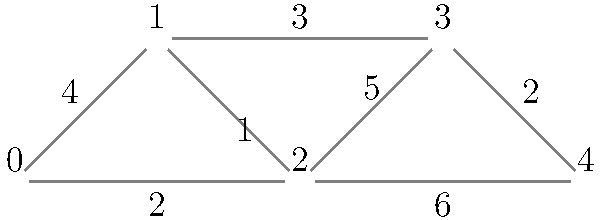Given the network topology represented by the graph, where vertices are iOS app components and edge weights represent communication costs, determine the minimum spanning tree that optimizes the app's performance. What is the total cost of this optimal configuration? To find the minimum spanning tree (MST) and its total cost, we'll use Kruskal's algorithm, which is efficient and doesn't require excessive typecasting:

1. Sort edges by weight in ascending order:
   (1, 2): 1
   (0, 2): 2
   (3, 4): 2
   (1, 3): 3
   (0, 1): 4
   (2, 3): 5
   (2, 4): 6

2. Add edges to the MST, skipping those that create cycles:
   - Add (1, 2): 1
   - Add (0, 2): 2
   - Add (3, 4): 2
   - Add (1, 3): 3

3. Stop as we have included 4 edges (n-1 where n is the number of vertices).

4. The MST consists of edges: (1, 2), (0, 2), (3, 4), and (1, 3).

5. Calculate the total cost: 1 + 2 + 2 + 3 = 8.

This approach avoids excessive typecasting by working directly with the edge weights and using a simple sorting algorithm.
Answer: 8 